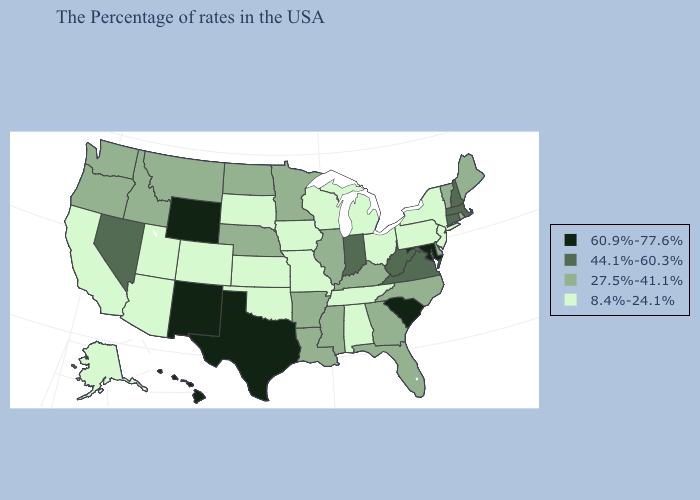What is the value of New Hampshire?
Keep it brief. 44.1%-60.3%. What is the value of Kansas?
Write a very short answer. 8.4%-24.1%. Which states have the highest value in the USA?
Concise answer only. Maryland, South Carolina, Texas, Wyoming, New Mexico, Hawaii. What is the lowest value in the Northeast?
Answer briefly. 8.4%-24.1%. What is the highest value in the South ?
Quick response, please. 60.9%-77.6%. What is the value of New Hampshire?
Give a very brief answer. 44.1%-60.3%. Does the first symbol in the legend represent the smallest category?
Answer briefly. No. What is the highest value in states that border New Hampshire?
Short answer required. 44.1%-60.3%. What is the value of North Carolina?
Concise answer only. 27.5%-41.1%. What is the highest value in the USA?
Be succinct. 60.9%-77.6%. Among the states that border Oklahoma , does Missouri have the highest value?
Short answer required. No. What is the lowest value in the USA?
Answer briefly. 8.4%-24.1%. What is the highest value in the MidWest ?
Keep it brief. 44.1%-60.3%. What is the value of New Hampshire?
Keep it brief. 44.1%-60.3%. 